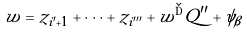Convert formula to latex. <formula><loc_0><loc_0><loc_500><loc_500>w = z _ { i ^ { \prime } + 1 } + \dots + z _ { i ^ { \prime \prime \prime } } + w ^ { \dag } Q ^ { \prime \prime } + \psi _ { \beta }</formula> 